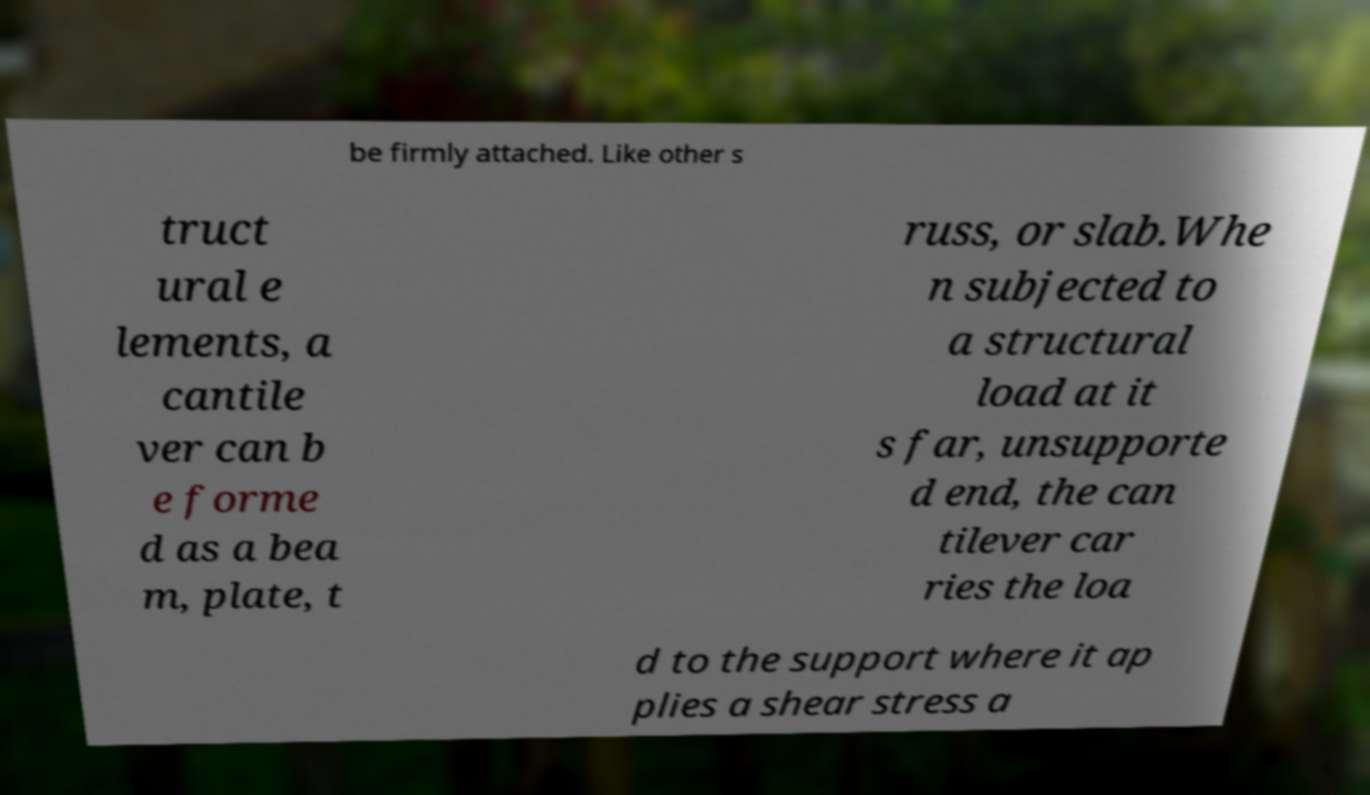Can you read and provide the text displayed in the image?This photo seems to have some interesting text. Can you extract and type it out for me? be firmly attached. Like other s truct ural e lements, a cantile ver can b e forme d as a bea m, plate, t russ, or slab.Whe n subjected to a structural load at it s far, unsupporte d end, the can tilever car ries the loa d to the support where it ap plies a shear stress a 